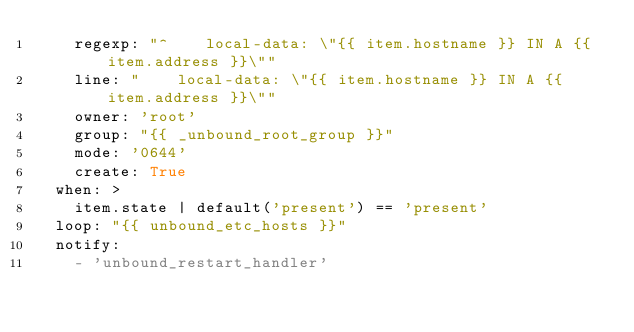Convert code to text. <code><loc_0><loc_0><loc_500><loc_500><_YAML_>    regexp: "^    local-data: \"{{ item.hostname }} IN A {{ item.address }}\""
    line: "    local-data: \"{{ item.hostname }} IN A {{ item.address }}\""
    owner: 'root'
    group: "{{ _unbound_root_group }}"
    mode: '0644'
    create: True
  when: >
    item.state | default('present') == 'present'
  loop: "{{ unbound_etc_hosts }}"
  notify:
    - 'unbound_restart_handler'
</code> 